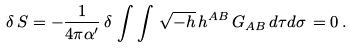Convert formula to latex. <formula><loc_0><loc_0><loc_500><loc_500>\delta \, S = - \frac { 1 } { 4 \pi { \alpha } ^ { \prime } } \, \delta \, \int \int \, \sqrt { - h } \, h ^ { A B } \, G _ { A B } \, d \tau d \sigma \, = 0 \, .</formula> 